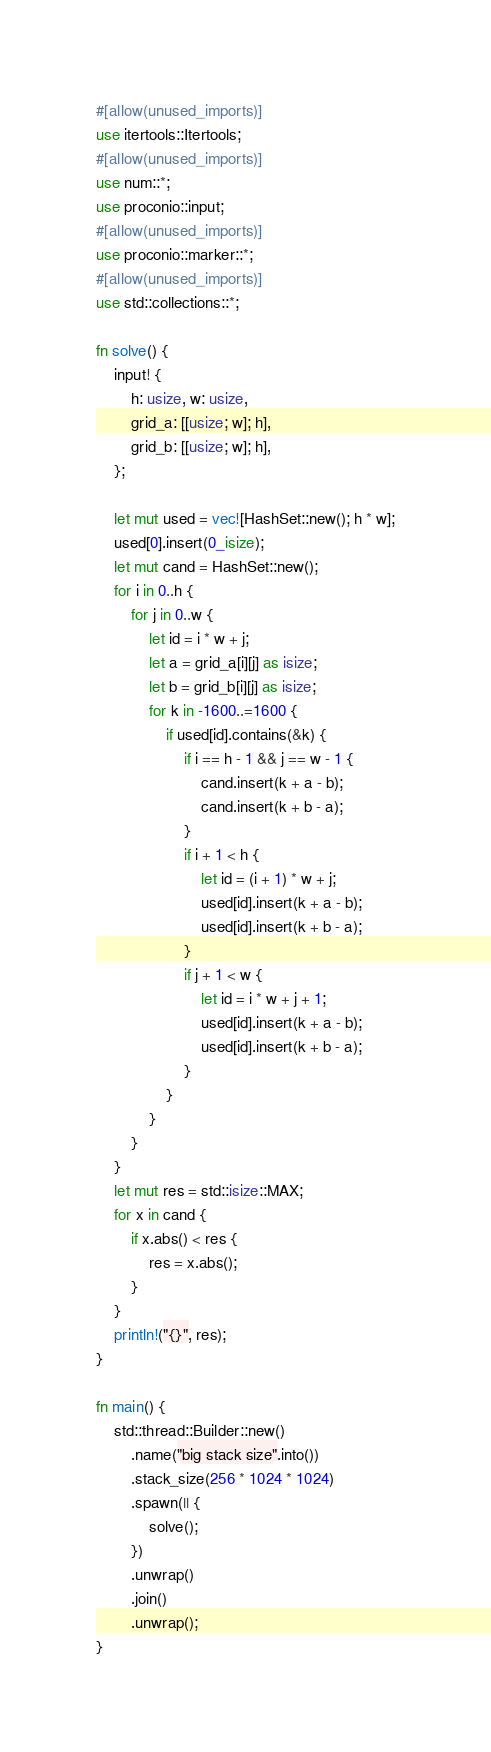<code> <loc_0><loc_0><loc_500><loc_500><_Rust_>#[allow(unused_imports)]
use itertools::Itertools;
#[allow(unused_imports)]
use num::*;
use proconio::input;
#[allow(unused_imports)]
use proconio::marker::*;
#[allow(unused_imports)]
use std::collections::*;

fn solve() {
    input! {
        h: usize, w: usize,
        grid_a: [[usize; w]; h],
        grid_b: [[usize; w]; h],
    };

    let mut used = vec![HashSet::new(); h * w];
    used[0].insert(0_isize);
    let mut cand = HashSet::new();
    for i in 0..h {
        for j in 0..w {
            let id = i * w + j;
            let a = grid_a[i][j] as isize;
            let b = grid_b[i][j] as isize;
            for k in -1600..=1600 {
                if used[id].contains(&k) {
                    if i == h - 1 && j == w - 1 {
                        cand.insert(k + a - b);
                        cand.insert(k + b - a);
                    }
                    if i + 1 < h {
                        let id = (i + 1) * w + j;
                        used[id].insert(k + a - b);
                        used[id].insert(k + b - a);
                    }
                    if j + 1 < w {
                        let id = i * w + j + 1;
                        used[id].insert(k + a - b);
                        used[id].insert(k + b - a);
                    }
                }
            }
        }
    }
    let mut res = std::isize::MAX;
    for x in cand {
        if x.abs() < res {
            res = x.abs();
        }
    }
    println!("{}", res);
}

fn main() {
    std::thread::Builder::new()
        .name("big stack size".into())
        .stack_size(256 * 1024 * 1024)
        .spawn(|| {
            solve();
        })
        .unwrap()
        .join()
        .unwrap();
}
</code> 